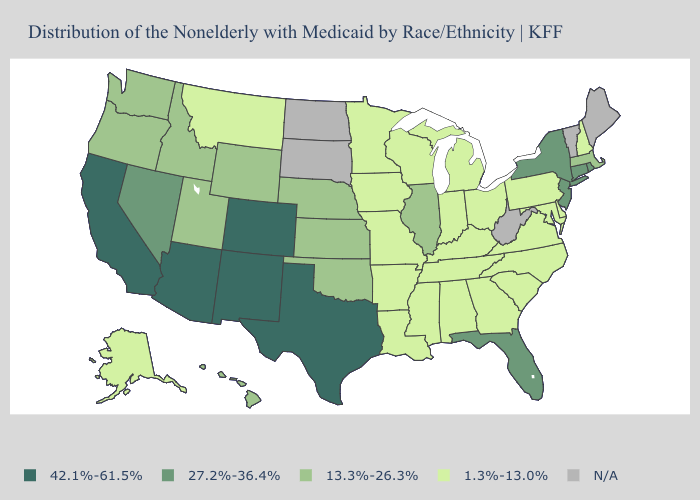What is the highest value in the USA?
Concise answer only. 42.1%-61.5%. What is the lowest value in the Northeast?
Write a very short answer. 1.3%-13.0%. Among the states that border California , does Arizona have the lowest value?
Be succinct. No. Among the states that border New Jersey , which have the highest value?
Short answer required. New York. What is the value of Michigan?
Be succinct. 1.3%-13.0%. Among the states that border Delaware , does New Jersey have the lowest value?
Quick response, please. No. What is the lowest value in the USA?
Short answer required. 1.3%-13.0%. Which states have the lowest value in the USA?
Short answer required. Alabama, Alaska, Arkansas, Delaware, Georgia, Indiana, Iowa, Kentucky, Louisiana, Maryland, Michigan, Minnesota, Mississippi, Missouri, Montana, New Hampshire, North Carolina, Ohio, Pennsylvania, South Carolina, Tennessee, Virginia, Wisconsin. Which states have the lowest value in the USA?
Short answer required. Alabama, Alaska, Arkansas, Delaware, Georgia, Indiana, Iowa, Kentucky, Louisiana, Maryland, Michigan, Minnesota, Mississippi, Missouri, Montana, New Hampshire, North Carolina, Ohio, Pennsylvania, South Carolina, Tennessee, Virginia, Wisconsin. Name the states that have a value in the range 13.3%-26.3%?
Give a very brief answer. Hawaii, Idaho, Illinois, Kansas, Massachusetts, Nebraska, Oklahoma, Oregon, Utah, Washington, Wyoming. Name the states that have a value in the range 13.3%-26.3%?
Be succinct. Hawaii, Idaho, Illinois, Kansas, Massachusetts, Nebraska, Oklahoma, Oregon, Utah, Washington, Wyoming. Among the states that border Montana , which have the highest value?
Write a very short answer. Idaho, Wyoming. What is the value of West Virginia?
Answer briefly. N/A. 